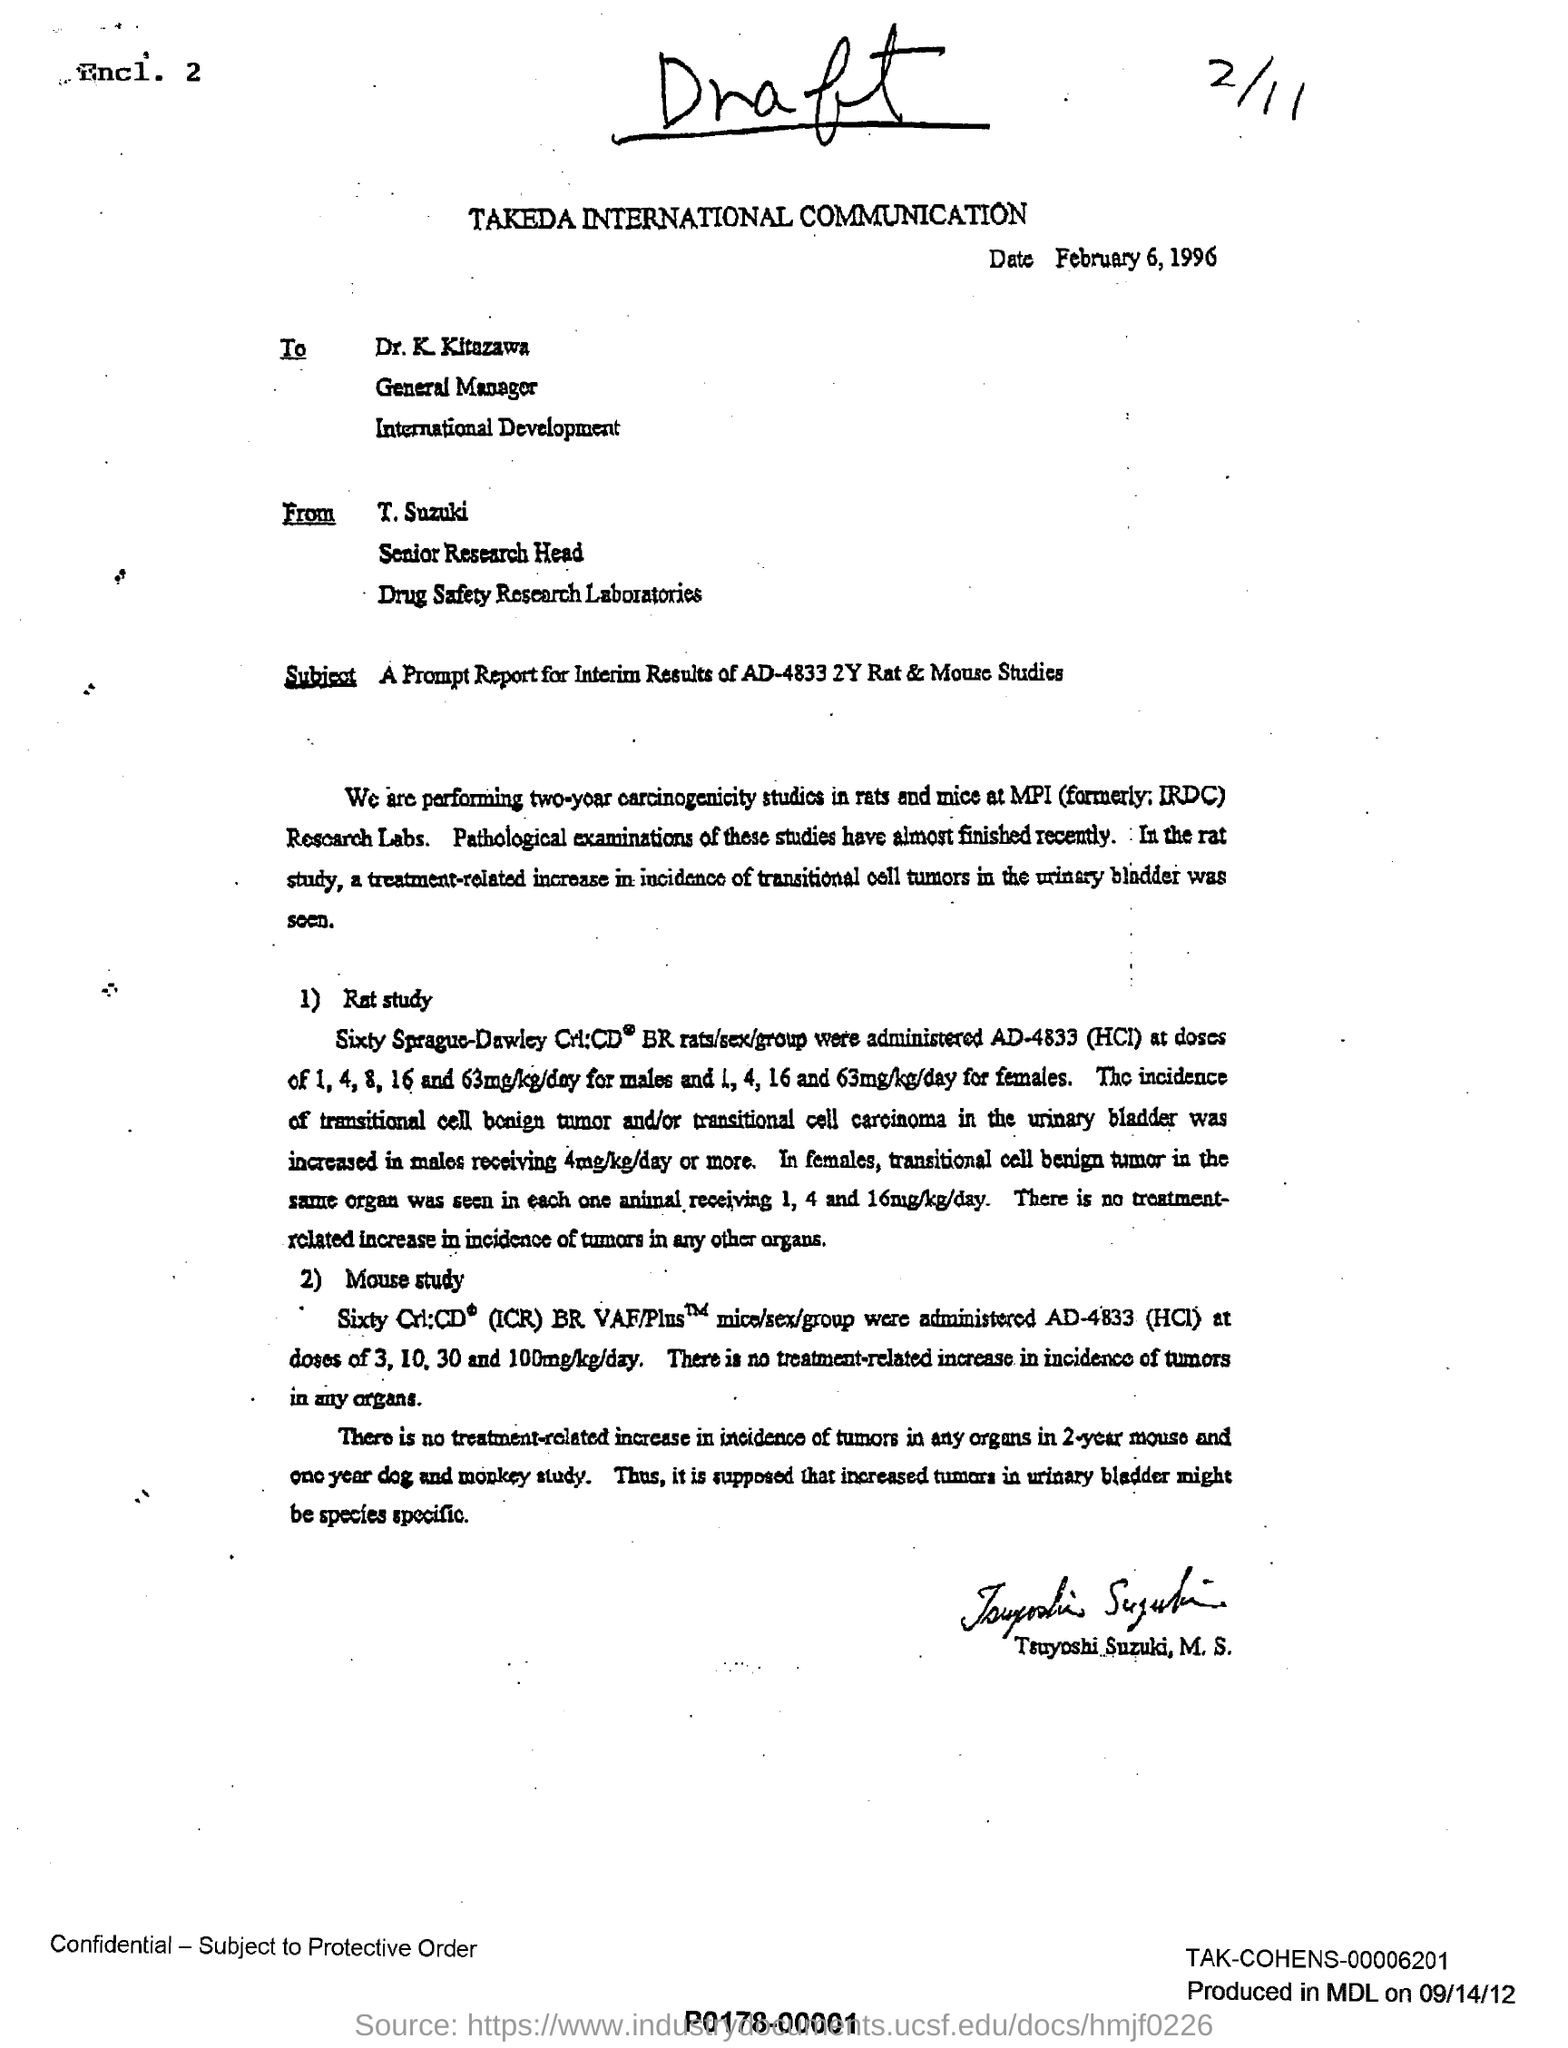Give some essential details in this illustration. The date mentioned is February 6, 1996. This letter is written by T. Suzuki. T. Suzuki is associated with the drug safety research laboratories. 